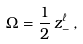<formula> <loc_0><loc_0><loc_500><loc_500>\Omega = \frac { 1 } { 2 } \, z _ { - } ^ { \ell } \, ,</formula> 